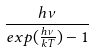<formula> <loc_0><loc_0><loc_500><loc_500>\frac { h \nu } { e x p ( \frac { h \nu } { k T } ) - 1 }</formula> 